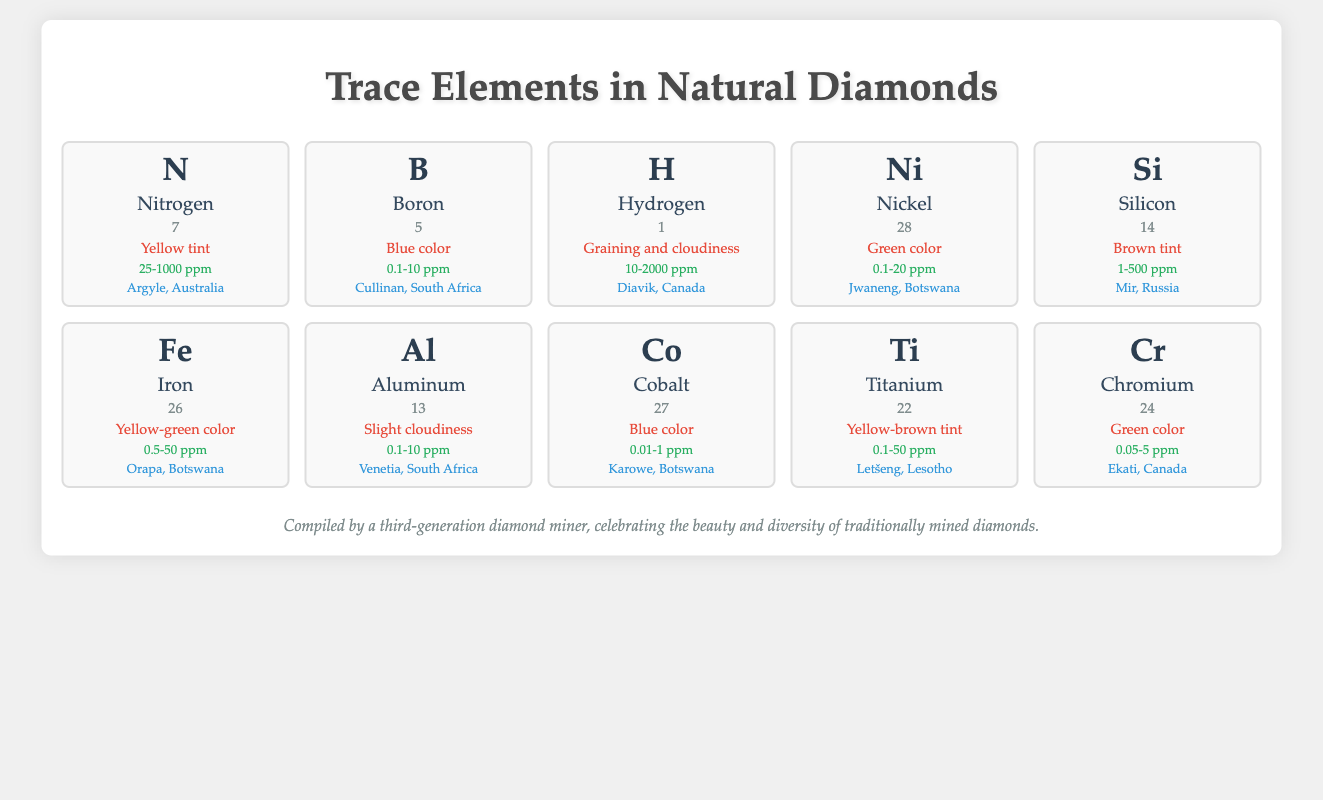What is the effect of Nitrogen on diamond color? According to the table, Nitrogen causes a yellow tint in diamonds. Therefore, the effect of Nitrogen on diamond color is a yellow tint.
Answer: Yellow tint Which trace element contributes to a blue color in diamonds? The table shows that Boron and Cobalt both contribute to blue color in diamonds. Boron has a higher concentration range compared to Cobalt, making it a more common contributor.
Answer: Boron and Cobalt What is the concentration range of Hydrogen found in diamonds? In the table, it is specified that the concentration of Hydrogen ranges from 10 to 2000 ppm. This information can be directly retrieved from the table.
Answer: 10-2000 ppm Is Aluminum known to cause a color effect in diamonds? The table indicates that Aluminum results in slight cloudiness, which is not a color effect, but rather affects transparency. So, the answer is no.
Answer: No Which trace element has the lowest concentration range listed? Examining the concentration ranges in the table, Cobalt has the lowest range from 0.01 to 1 ppm, thus making it the element with the lowest concentration range.
Answer: Cobalt (0.01-1 ppm) How many trace elements contribute to green color in diamonds? From the table, both Nickel and Chromium contribute to green color in diamonds, making a total of two trace elements that result in this color.
Answer: Two What is the average concentration of Iron among trace elements affecting color? Iron's concentration range is 0.5-50 ppm. To find an average, we use the midpoint (0.5 + 50) / 2 = 25.25 ppm. Thus, the average concentration of Iron is approximately 25.25 ppm.
Answer: 25.25 ppm Which location is associated with the highest concentration range of trace elements among those listed? Reviewing the concentration ranges, Hydrogen (10-2000 ppm) has the widest range. Therefore, the location associated with the highest concentration is Diavik, Canada, with the element Hydrogen.
Answer: Diavik, Canada (Hydrogen) Does Silicon have a concentration range that exceeds 500 ppm? The table states the concentration range for Silicon is 1-500 ppm, which does not exceed 500 ppm. Thus, the answer is no.
Answer: No What effect does Titanium have on diamond color? The table designates Titanium as having a yellow-brown tint effect on diamond color. Thus, it affects the color in this specific way.
Answer: Yellow-brown tint 